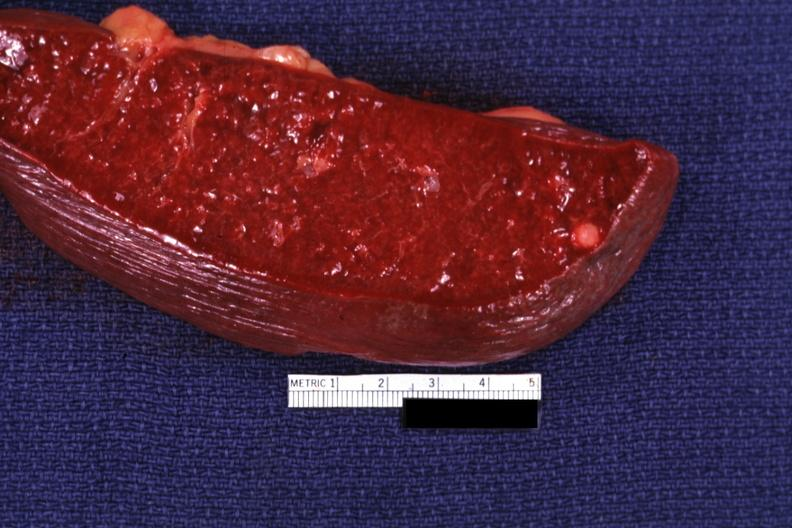what is present?
Answer the question using a single word or phrase. Spleen 